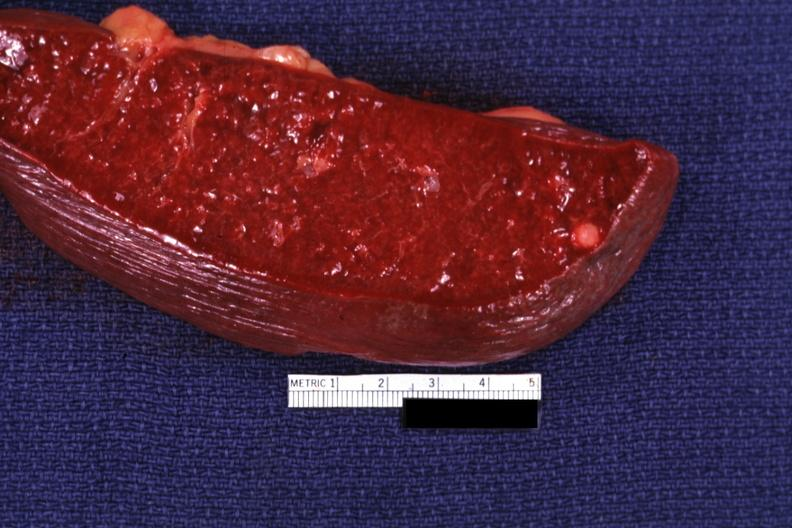what is present?
Answer the question using a single word or phrase. Spleen 